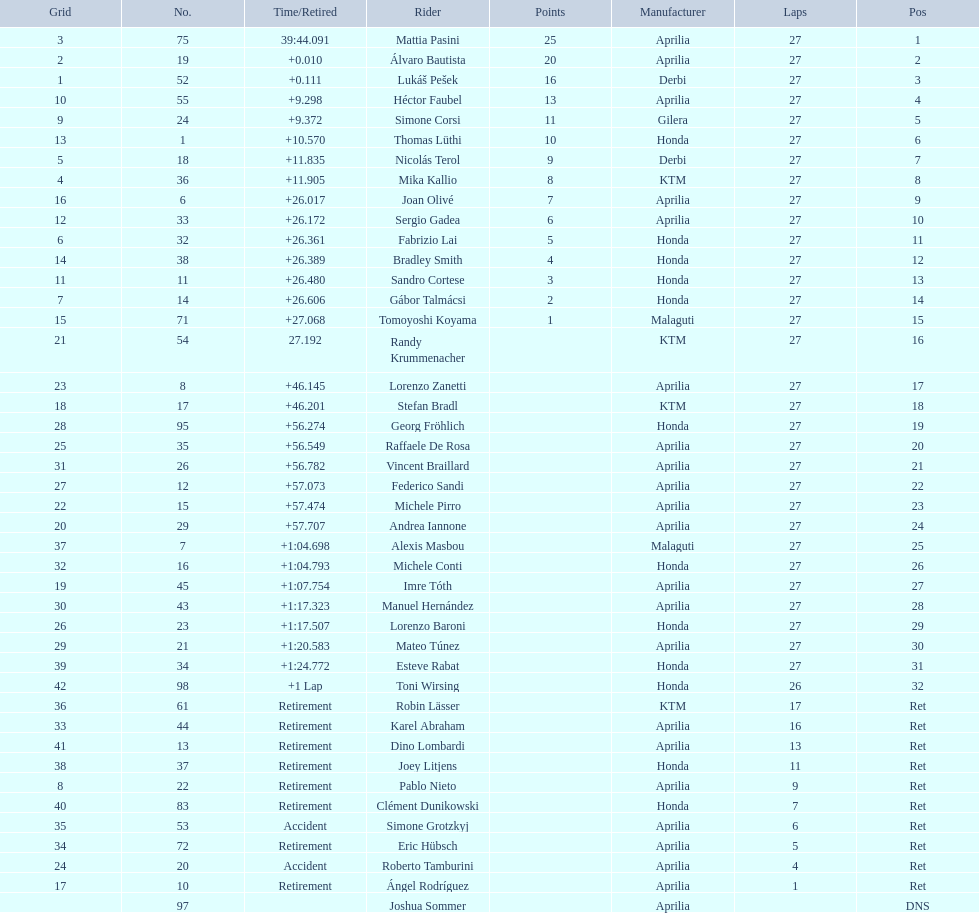How many competitors avoided using aprilia or honda motorcycles? 9. 